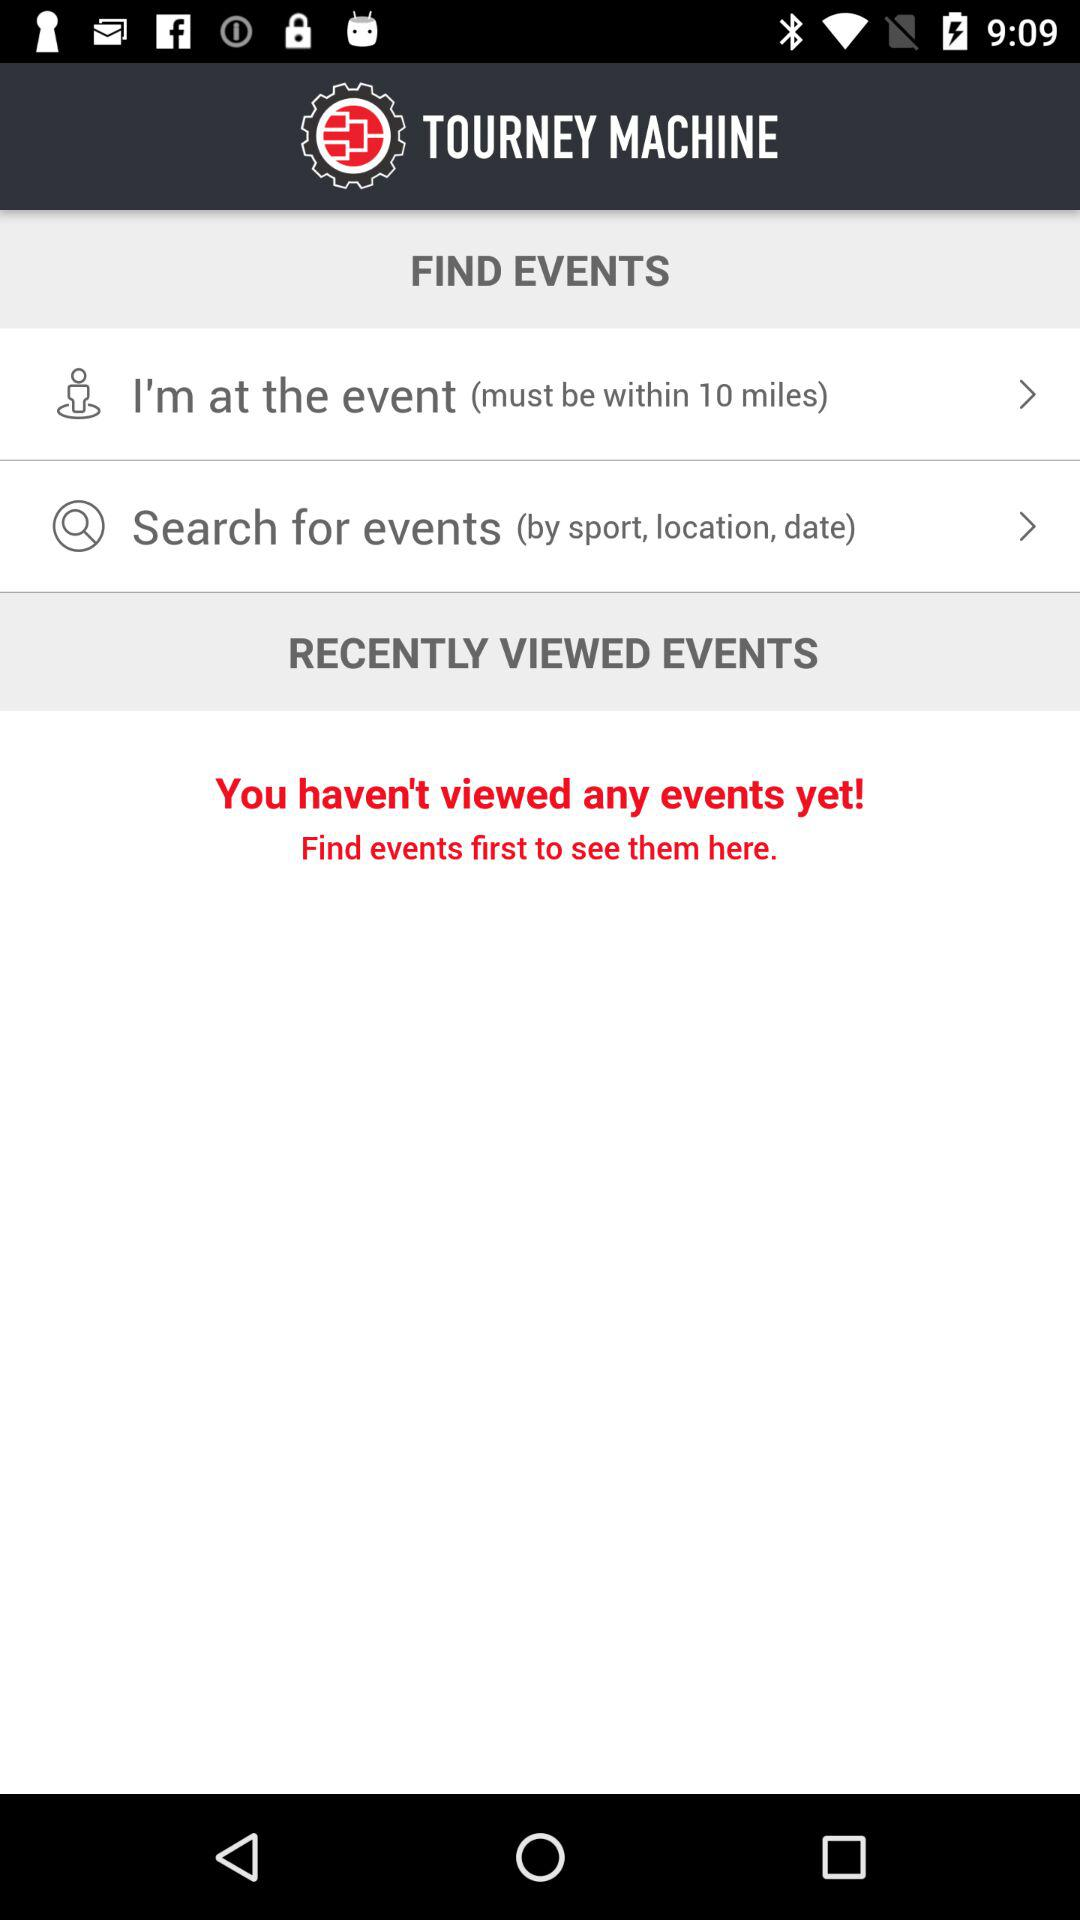What is the name of the application? The name of the application is "TOURNEY MACHINE". 